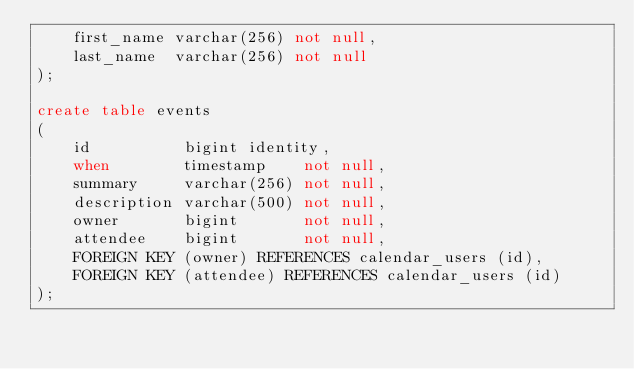<code> <loc_0><loc_0><loc_500><loc_500><_SQL_>    first_name varchar(256) not null,
    last_name  varchar(256) not null
);

create table events
(
    id          bigint identity,
    when        timestamp    not null,
    summary     varchar(256) not null,
    description varchar(500) not null,
    owner       bigint       not null,
    attendee    bigint       not null,
    FOREIGN KEY (owner) REFERENCES calendar_users (id),
    FOREIGN KEY (attendee) REFERENCES calendar_users (id)
);</code> 